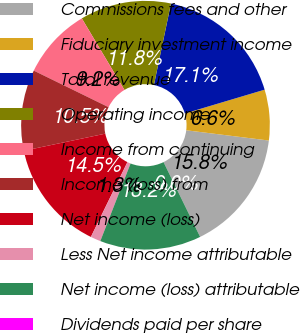<chart> <loc_0><loc_0><loc_500><loc_500><pie_chart><fcel>Commissions fees and other<fcel>Fiduciary investment income<fcel>Total revenue<fcel>Operating income<fcel>Income from continuing<fcel>Income (loss) from<fcel>Net income (loss)<fcel>Less Net income attributable<fcel>Net income (loss) attributable<fcel>Dividends paid per share<nl><fcel>15.79%<fcel>6.58%<fcel>17.1%<fcel>11.84%<fcel>9.21%<fcel>10.53%<fcel>14.47%<fcel>1.32%<fcel>13.16%<fcel>0.0%<nl></chart> 